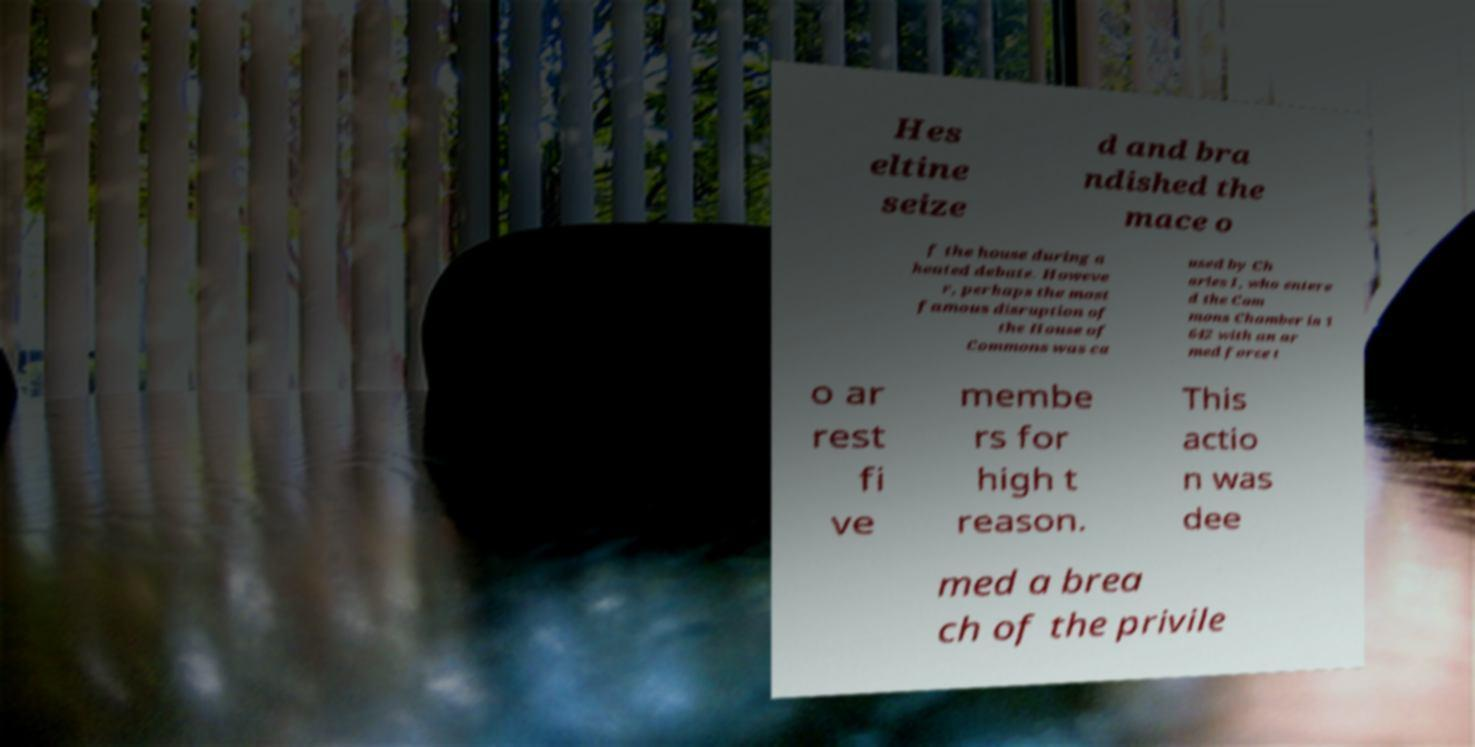Could you assist in decoding the text presented in this image and type it out clearly? Hes eltine seize d and bra ndished the mace o f the house during a heated debate. Howeve r, perhaps the most famous disruption of the House of Commons was ca used by Ch arles I, who entere d the Com mons Chamber in 1 642 with an ar med force t o ar rest fi ve membe rs for high t reason. This actio n was dee med a brea ch of the privile 